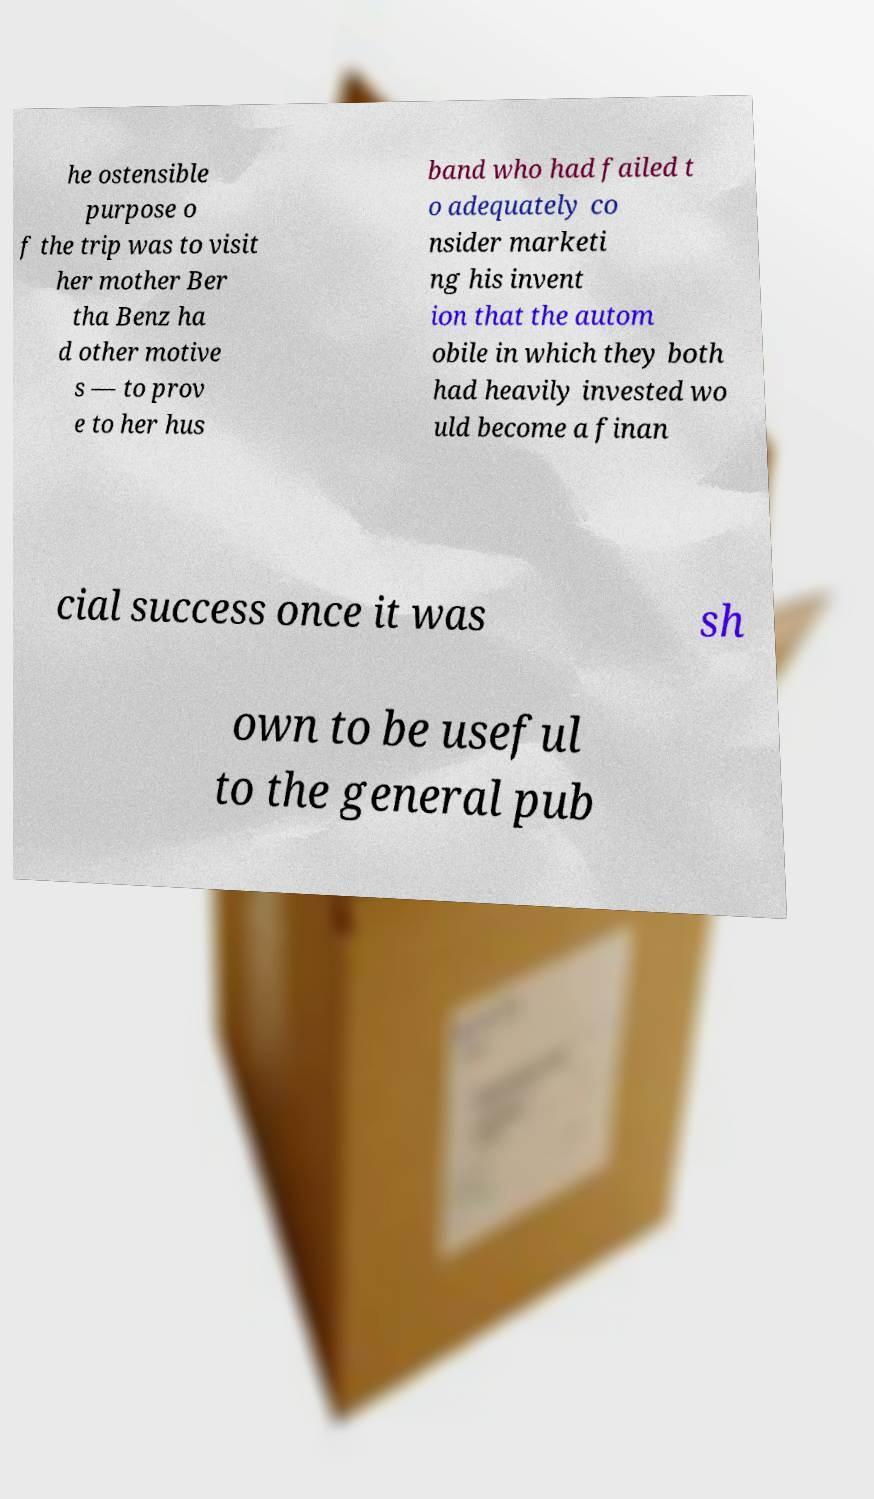Please identify and transcribe the text found in this image. he ostensible purpose o f the trip was to visit her mother Ber tha Benz ha d other motive s — to prov e to her hus band who had failed t o adequately co nsider marketi ng his invent ion that the autom obile in which they both had heavily invested wo uld become a finan cial success once it was sh own to be useful to the general pub 